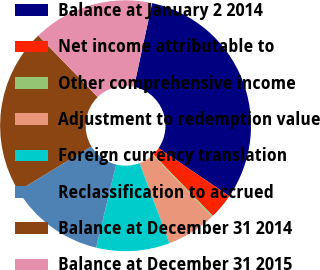<chart> <loc_0><loc_0><loc_500><loc_500><pie_chart><fcel>Balance at January 2 2014<fcel>Net income attributable to<fcel>Other comprehensive income<fcel>Adjustment to redemption value<fcel>Foreign currency translation<fcel>Reclassification to accrued<fcel>Balance at December 31 2014<fcel>Balance at December 31 2015<nl><fcel>31.1%<fcel>3.27%<fcel>0.18%<fcel>6.37%<fcel>9.46%<fcel>12.55%<fcel>21.43%<fcel>15.64%<nl></chart> 